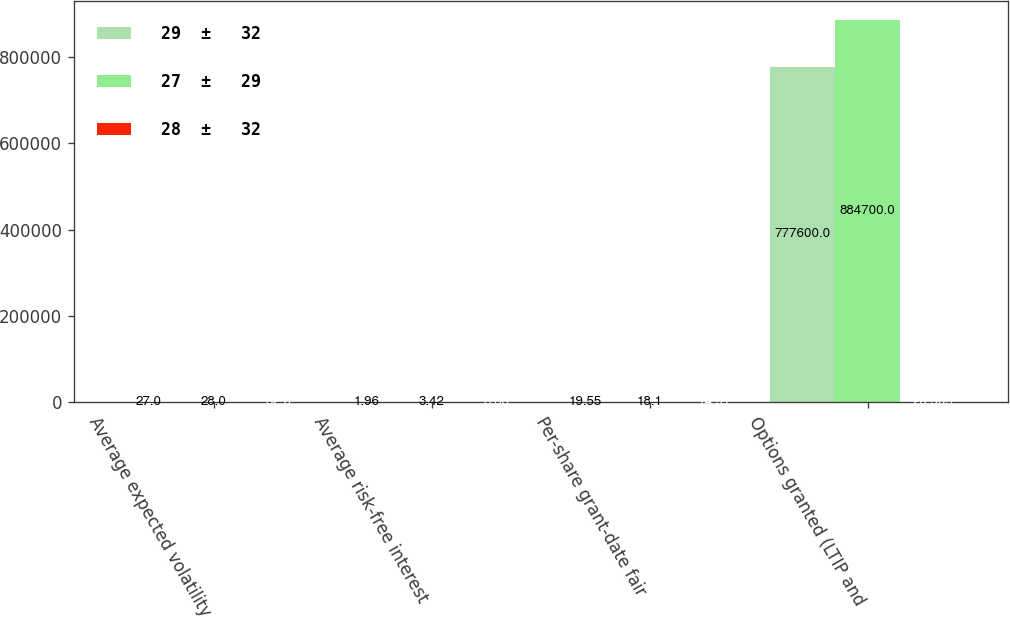Convert chart to OTSL. <chart><loc_0><loc_0><loc_500><loc_500><stacked_bar_chart><ecel><fcel>Average expected volatility<fcel>Average risk-free interest<fcel>Per-share grant-date fair<fcel>Options granted (LTIP and<nl><fcel>29  ±   32<fcel>27<fcel>1.96<fcel>19.55<fcel>777600<nl><fcel>27  ±   29<fcel>28<fcel>3.42<fcel>18.1<fcel>884700<nl><fcel>28  ±   32<fcel>32<fcel>3.63<fcel>14.91<fcel>20.905<nl></chart> 